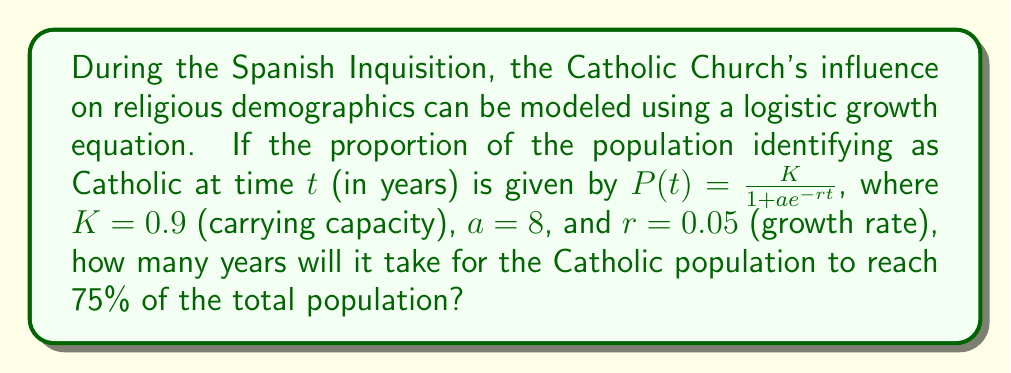Teach me how to tackle this problem. To solve this problem, we'll follow these steps:

1) The logistic growth equation is given by:
   $$P(t) = \frac{K}{1 + ae^{-rt}}$$

2) We're looking for the time $t$ when $P(t) = 0.75$ (75% of the population). Let's substitute the known values:

   $$0.75 = \frac{0.9}{1 + 8e^{-0.05t}}$$

3) Multiply both sides by the denominator:
   $$0.75(1 + 8e^{-0.05t}) = 0.9$$

4) Distribute on the left side:
   $$0.75 + 6e^{-0.05t} = 0.9$$

5) Subtract 0.75 from both sides:
   $$6e^{-0.05t} = 0.15$$

6) Divide both sides by 6:
   $$e^{-0.05t} = 0.025$$

7) Take the natural log of both sides:
   $$-0.05t = \ln(0.025)$$

8) Divide both sides by -0.05:
   $$t = \frac{\ln(0.025)}{-0.05}$$

9) Calculate the result:
   $$t \approx 73.70$$

10) Since we're dealing with years, we round up to the nearest whole number.
Answer: 74 years 